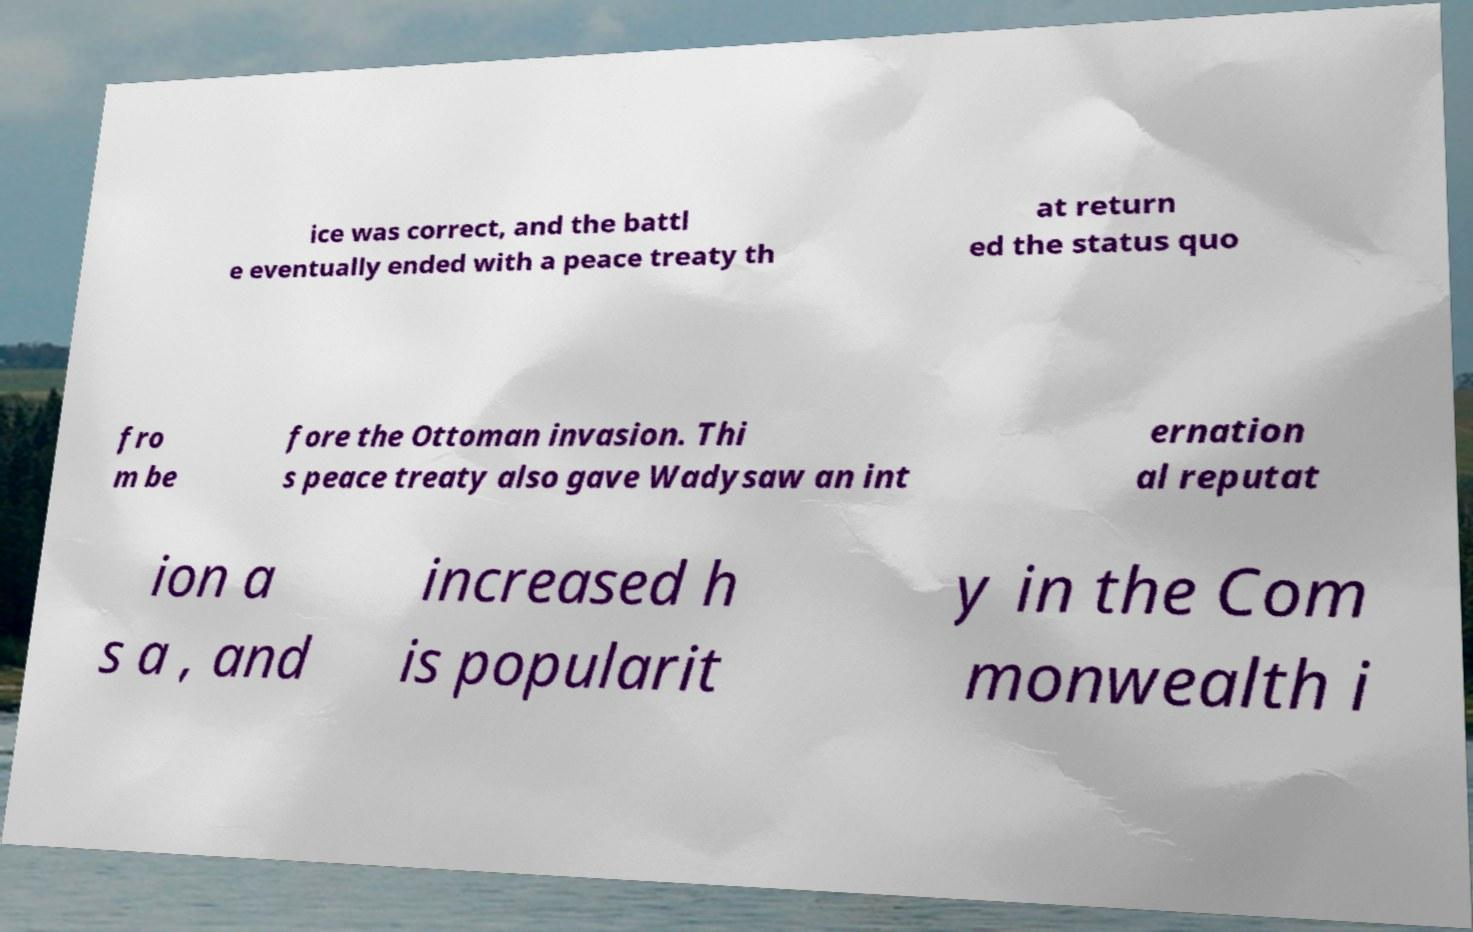Could you extract and type out the text from this image? ice was correct, and the battl e eventually ended with a peace treaty th at return ed the status quo fro m be fore the Ottoman invasion. Thi s peace treaty also gave Wadysaw an int ernation al reputat ion a s a , and increased h is popularit y in the Com monwealth i 